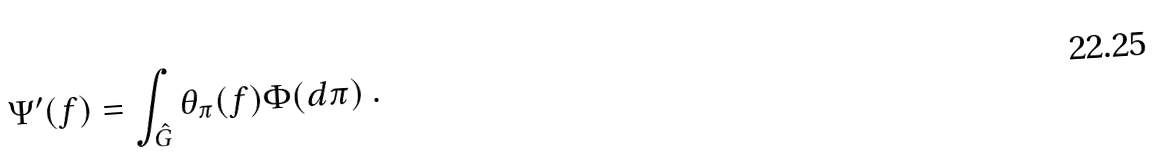<formula> <loc_0><loc_0><loc_500><loc_500>\Psi ^ { \prime } ( f ) = \int _ { \hat { G } } \theta _ { \pi } ( f ) \Phi ( d \pi ) \ .</formula> 